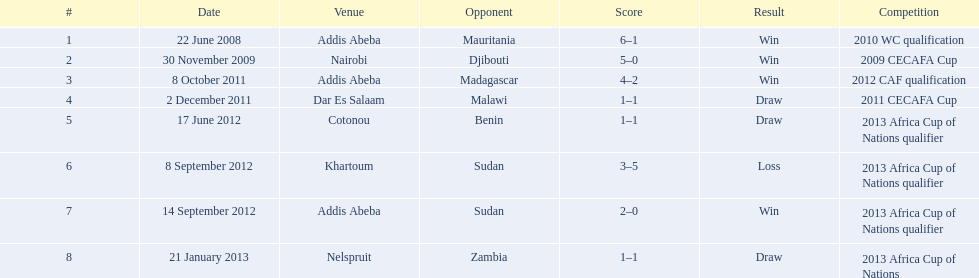True or false? when compared, the ethiopian national team has more ties than victories. False. 